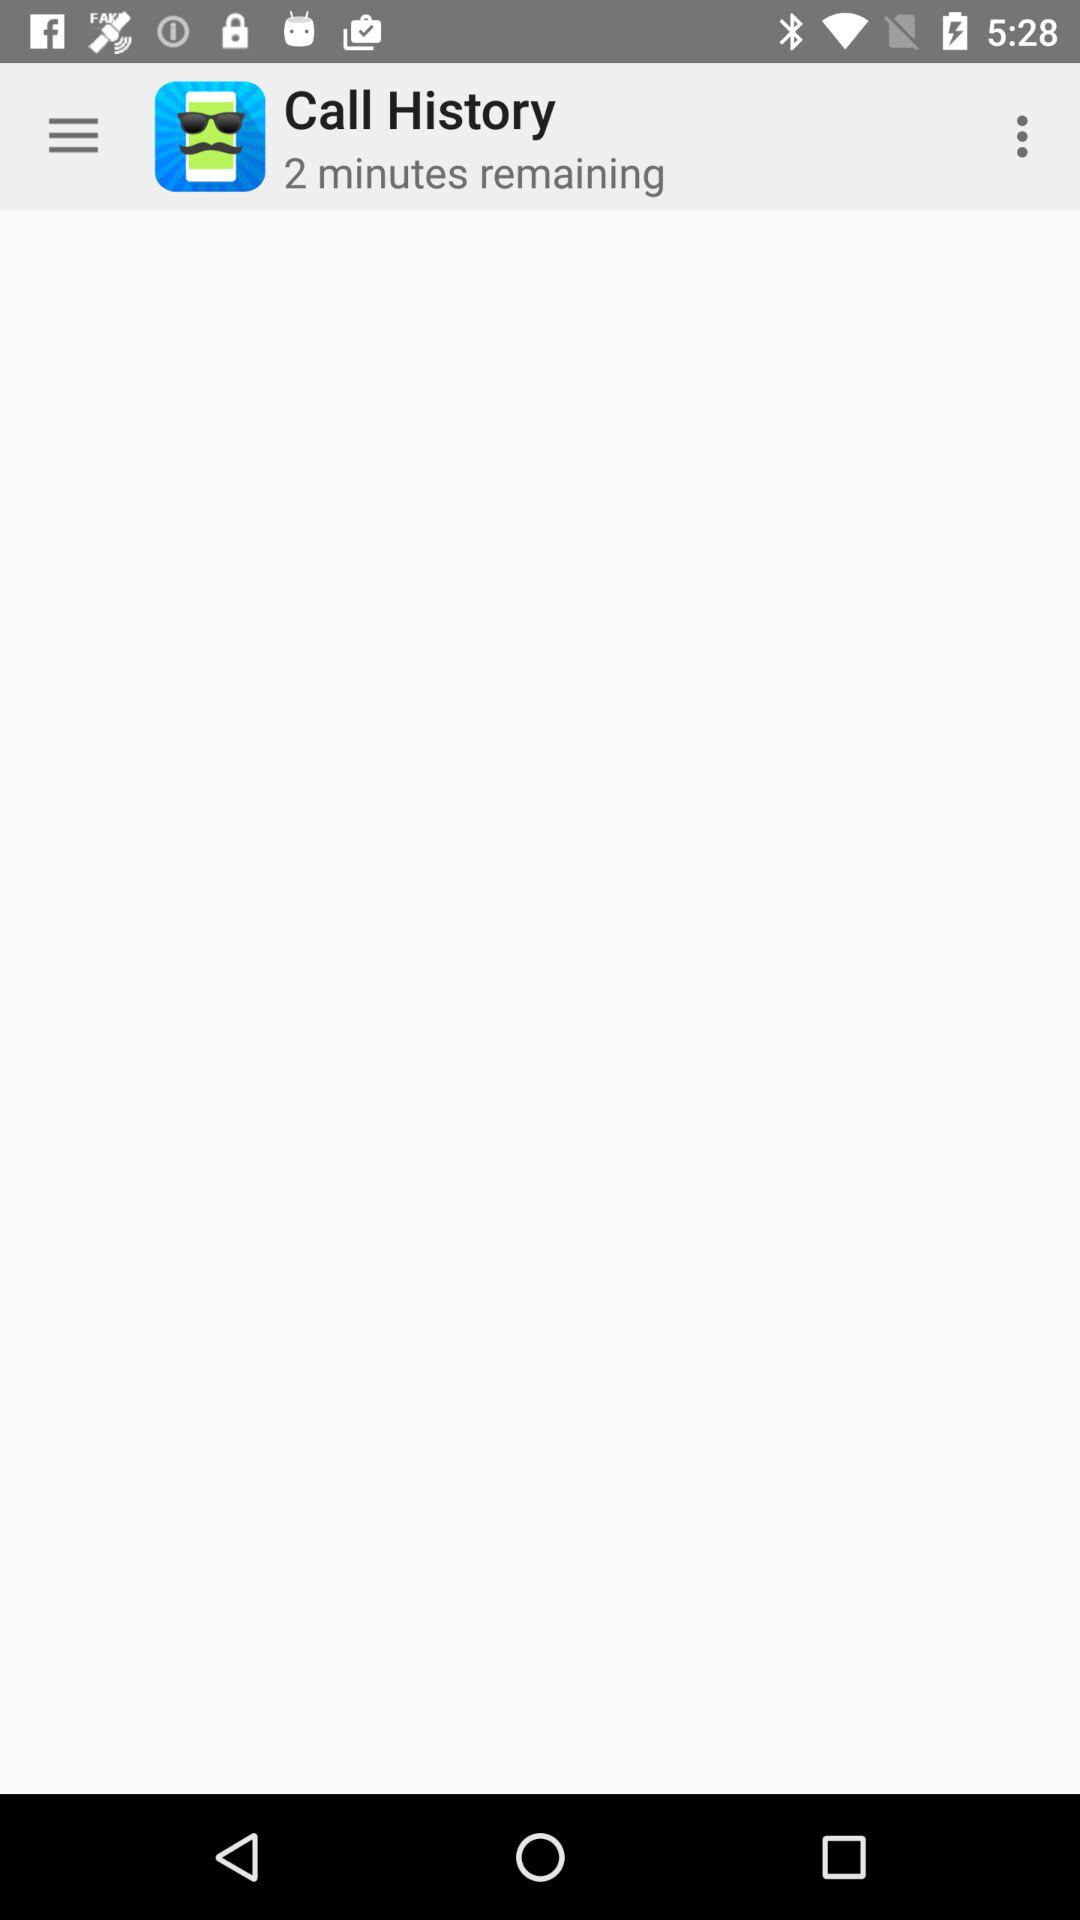How many minutes are remaining? There are 2 minutes remaining. 